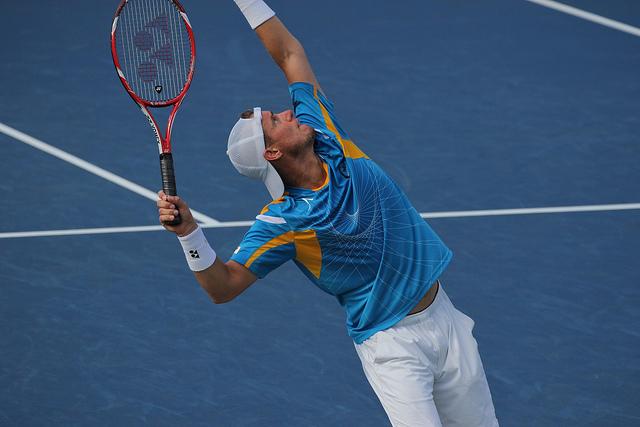What sport is the man playing?
Write a very short answer. Tennis. Is this player wearing a belt?
Give a very brief answer. No. What direction is the man looking?
Keep it brief. Up. How many stripes does the man's shirt have?
Be succinct. 2. What is the tennis court made of?
Keep it brief. Clay. 